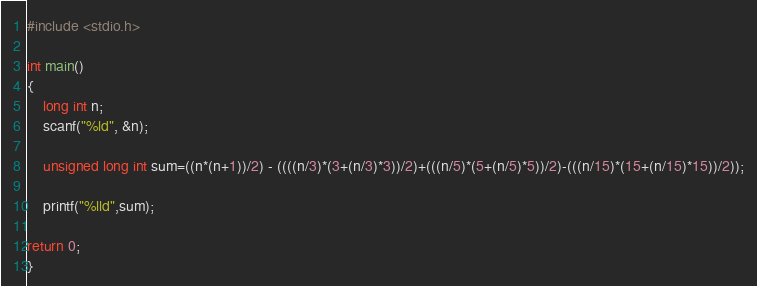Convert code to text. <code><loc_0><loc_0><loc_500><loc_500><_C_>#include <stdio.h>

int main()
{
	long int n;
	scanf("%ld", &n);
	
	unsigned long int sum=((n*(n+1))/2) - ((((n/3)*(3+(n/3)*3))/2)+(((n/5)*(5+(n/5)*5))/2)-(((n/15)*(15+(n/15)*15))/2));
	
	printf("%lld",sum);
	
return 0;
}</code> 